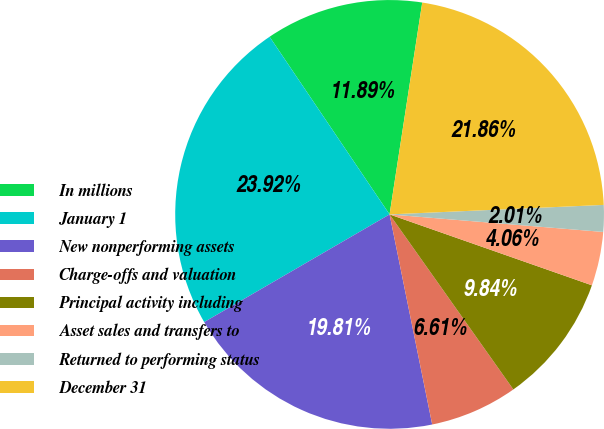Convert chart to OTSL. <chart><loc_0><loc_0><loc_500><loc_500><pie_chart><fcel>In millions<fcel>January 1<fcel>New nonperforming assets<fcel>Charge-offs and valuation<fcel>Principal activity including<fcel>Asset sales and transfers to<fcel>Returned to performing status<fcel>December 31<nl><fcel>11.89%<fcel>23.92%<fcel>19.81%<fcel>6.61%<fcel>9.84%<fcel>4.06%<fcel>2.01%<fcel>21.86%<nl></chart> 